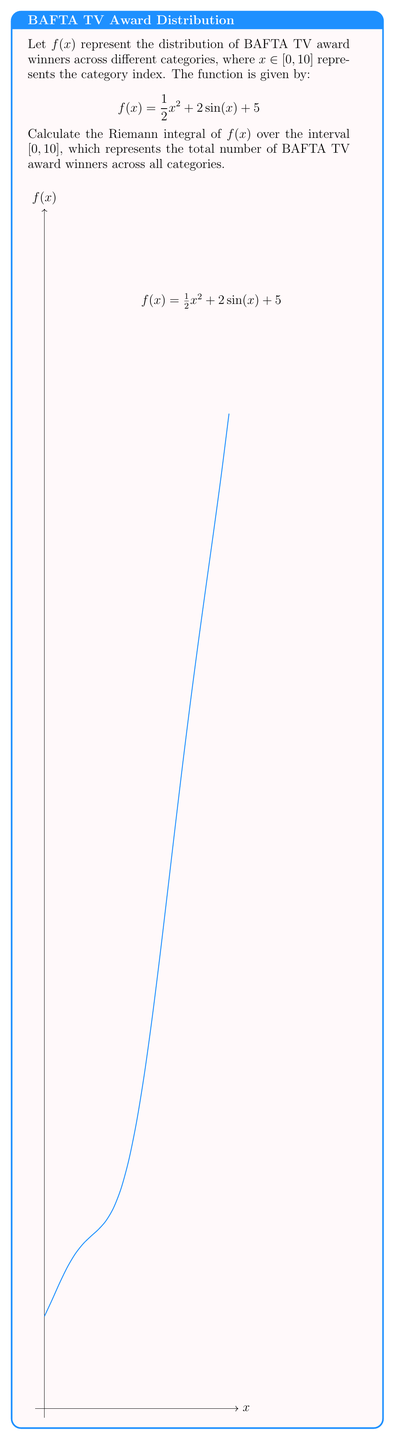Give your solution to this math problem. To calculate the Riemann integral of $f(x)$ over $[0, 10]$, we need to follow these steps:

1) The Riemann integral is given by:
   $$\int_0^{10} f(x) dx = \int_0^{10} (\frac{1}{2}x^2 + 2\sin(x) + 5) dx$$

2) We can split this into three integrals:
   $$\int_0^{10} \frac{1}{2}x^2 dx + \int_0^{10} 2\sin(x) dx + \int_0^{10} 5 dx$$

3) Let's solve each integral:

   a) $\int_0^{10} \frac{1}{2}x^2 dx = [\frac{1}{6}x^3]_0^{10} = \frac{1000}{6} - 0 = \frac{500}{3}$

   b) $\int_0^{10} 2\sin(x) dx = [-2\cos(x)]_0^{10} = -2\cos(10) + 2\cos(0) = -2\cos(10) + 2$

   c) $\int_0^{10} 5 dx = [5x]_0^{10} = 50 - 0 = 50$

4) Now, we sum these results:
   $$\frac{500}{3} + (-2\cos(10) + 2) + 50$$

5) Simplifying:
   $$\frac{500}{3} - 2\cos(10) + 52$$
Answer: $\frac{500}{3} - 2\cos(10) + 52$ 